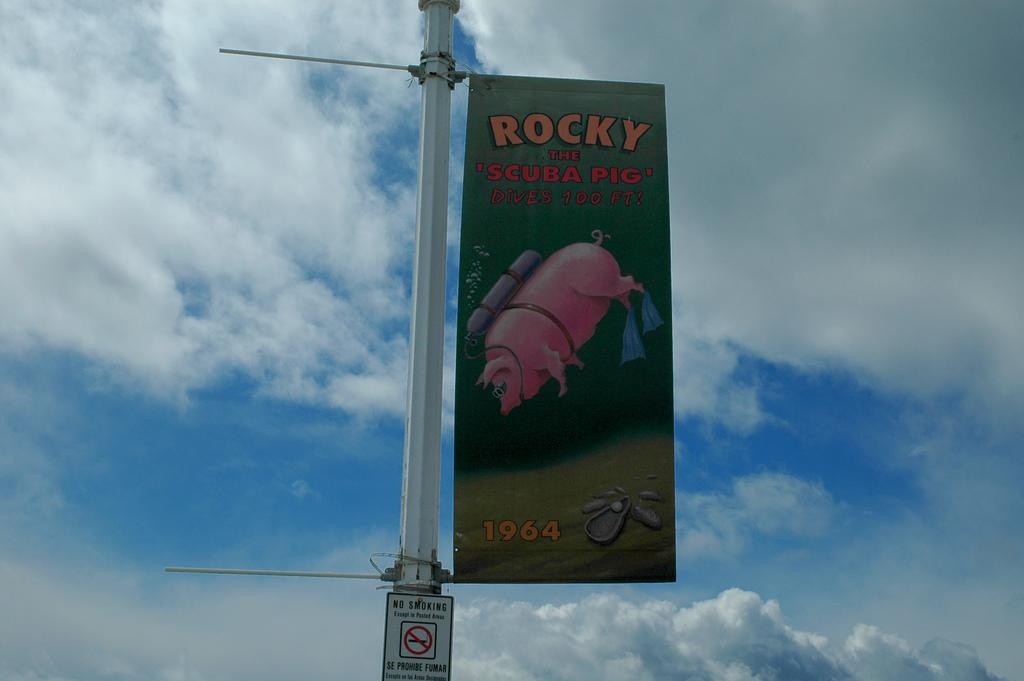<image>
Describe the image concisely. A sign advertized on a pole that says, Rocky the Scuba Pig Dives 100 FT! 1964. 